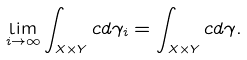Convert formula to latex. <formula><loc_0><loc_0><loc_500><loc_500>\lim _ { i \to \infty } \int _ { X \times Y } c d \gamma _ { i } = \int _ { X \times Y } c d \gamma .</formula> 